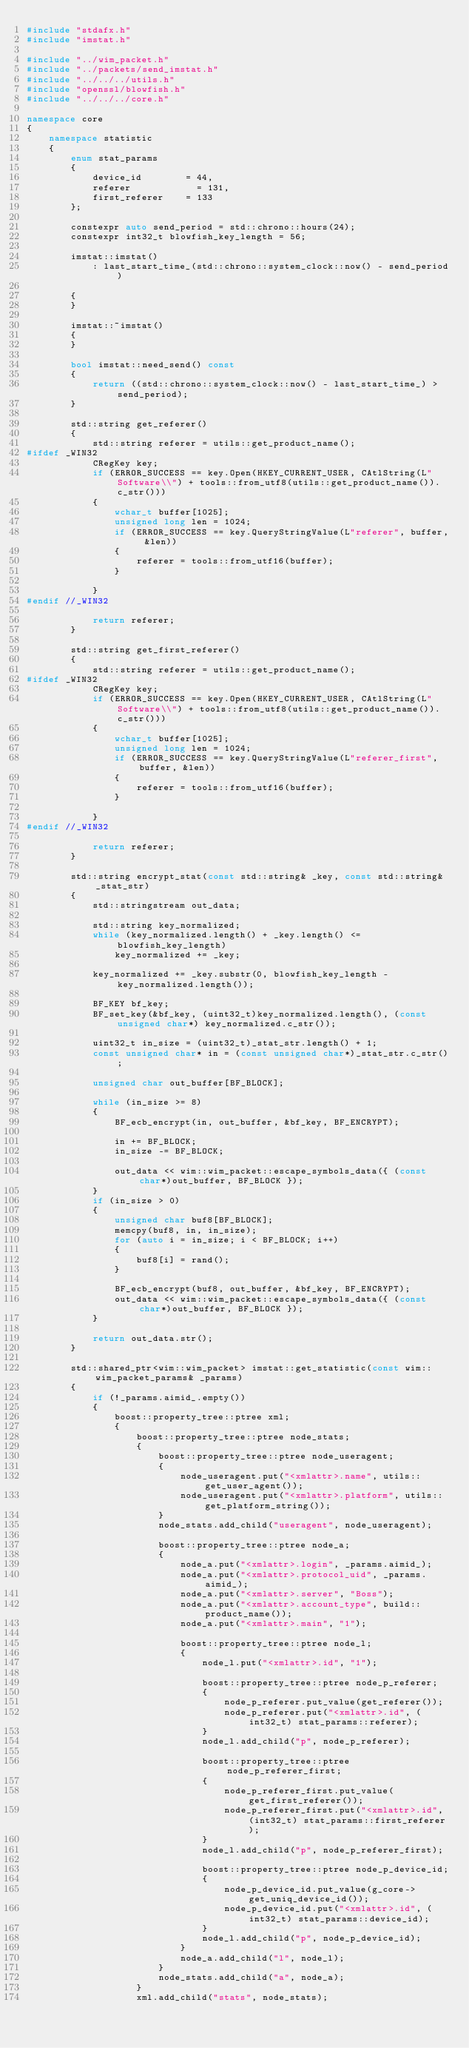<code> <loc_0><loc_0><loc_500><loc_500><_C++_>#include "stdafx.h"
#include "imstat.h"

#include "../wim_packet.h"
#include "../packets/send_imstat.h"
#include "../../../utils.h"
#include "openssl/blowfish.h"
#include "../../../core.h"

namespace core
{
    namespace statistic
    {
        enum stat_params
        {
            device_id        = 44,
            referer            = 131,
            first_referer    = 133
        };

        constexpr auto send_period = std::chrono::hours(24);
        constexpr int32_t blowfish_key_length = 56;

        imstat::imstat()
            : last_start_time_(std::chrono::system_clock::now() - send_period)

        {
        }

        imstat::~imstat()
        {
        }

        bool imstat::need_send() const
        {
            return ((std::chrono::system_clock::now() - last_start_time_) > send_period);
        }

        std::string get_referer()
        {
            std::string referer = utils::get_product_name();
#ifdef _WIN32
            CRegKey key;
            if (ERROR_SUCCESS == key.Open(HKEY_CURRENT_USER, CAtlString(L"Software\\") + tools::from_utf8(utils::get_product_name()).c_str()))
            {
                wchar_t buffer[1025];
                unsigned long len = 1024;
                if (ERROR_SUCCESS == key.QueryStringValue(L"referer", buffer, &len))
                {
                    referer = tools::from_utf16(buffer);
                }

            }
#endif //_WIN32

            return referer;
        }

        std::string get_first_referer()
        {
            std::string referer = utils::get_product_name();
#ifdef _WIN32
            CRegKey key;
            if (ERROR_SUCCESS == key.Open(HKEY_CURRENT_USER, CAtlString(L"Software\\") + tools::from_utf8(utils::get_product_name()).c_str()))
            {
                wchar_t buffer[1025];
                unsigned long len = 1024;
                if (ERROR_SUCCESS == key.QueryStringValue(L"referer_first", buffer, &len))
                {
                    referer = tools::from_utf16(buffer);
                }

            }
#endif //_WIN32

            return referer;
        }

        std::string encrypt_stat(const std::string& _key, const std::string& _stat_str)
        {
            std::stringstream out_data;

            std::string key_normalized;
            while (key_normalized.length() + _key.length() <= blowfish_key_length)
                key_normalized += _key;

            key_normalized += _key.substr(0, blowfish_key_length - key_normalized.length());

            BF_KEY bf_key;
            BF_set_key(&bf_key, (uint32_t)key_normalized.length(), (const unsigned char*) key_normalized.c_str());

            uint32_t in_size = (uint32_t)_stat_str.length() + 1;
            const unsigned char* in = (const unsigned char*)_stat_str.c_str();

            unsigned char out_buffer[BF_BLOCK];

            while (in_size >= 8)
            {
                BF_ecb_encrypt(in, out_buffer, &bf_key, BF_ENCRYPT);

                in += BF_BLOCK;
                in_size -= BF_BLOCK;

                out_data << wim::wim_packet::escape_symbols_data({ (const char*)out_buffer, BF_BLOCK });
            }
            if (in_size > 0)
            {
                unsigned char buf8[BF_BLOCK];
                memcpy(buf8, in, in_size);
                for (auto i = in_size; i < BF_BLOCK; i++)
                {
                    buf8[i] = rand();
                }

                BF_ecb_encrypt(buf8, out_buffer, &bf_key, BF_ENCRYPT);
                out_data << wim::wim_packet::escape_symbols_data({ (const char*)out_buffer, BF_BLOCK });
            }

            return out_data.str();
        }

        std::shared_ptr<wim::wim_packet> imstat::get_statistic(const wim::wim_packet_params& _params)
        {
            if (!_params.aimid_.empty())
            {
                boost::property_tree::ptree xml;
                {
                    boost::property_tree::ptree node_stats;
                    {
                        boost::property_tree::ptree node_useragent;
                        {
                            node_useragent.put("<xmlattr>.name", utils::get_user_agent());
                            node_useragent.put("<xmlattr>.platform", utils::get_platform_string());
                        }
                        node_stats.add_child("useragent", node_useragent);

                        boost::property_tree::ptree node_a;
                        {
                            node_a.put("<xmlattr>.login", _params.aimid_);
                            node_a.put("<xmlattr>.protocol_uid", _params.aimid_);
                            node_a.put("<xmlattr>.server", "Boss");
                            node_a.put("<xmlattr>.account_type", build::product_name());
                            node_a.put("<xmlattr>.main", "1");

                            boost::property_tree::ptree node_l;
                            {
                                node_l.put("<xmlattr>.id", "1");

                                boost::property_tree::ptree node_p_referer;
                                {
                                    node_p_referer.put_value(get_referer());
                                    node_p_referer.put("<xmlattr>.id", (int32_t) stat_params::referer);
                                }
                                node_l.add_child("p", node_p_referer);

                                boost::property_tree::ptree node_p_referer_first;
                                {
                                    node_p_referer_first.put_value(get_first_referer());
                                    node_p_referer_first.put("<xmlattr>.id", (int32_t) stat_params::first_referer);
                                }
                                node_l.add_child("p", node_p_referer_first);

                                boost::property_tree::ptree node_p_device_id;
                                {
                                    node_p_device_id.put_value(g_core->get_uniq_device_id());
                                    node_p_device_id.put("<xmlattr>.id", (int32_t) stat_params::device_id);
                                }
                                node_l.add_child("p", node_p_device_id);
                            }
                            node_a.add_child("l", node_l);
                        }
                        node_stats.add_child("a", node_a);
                    }
                    xml.add_child("stats", node_stats);</code> 